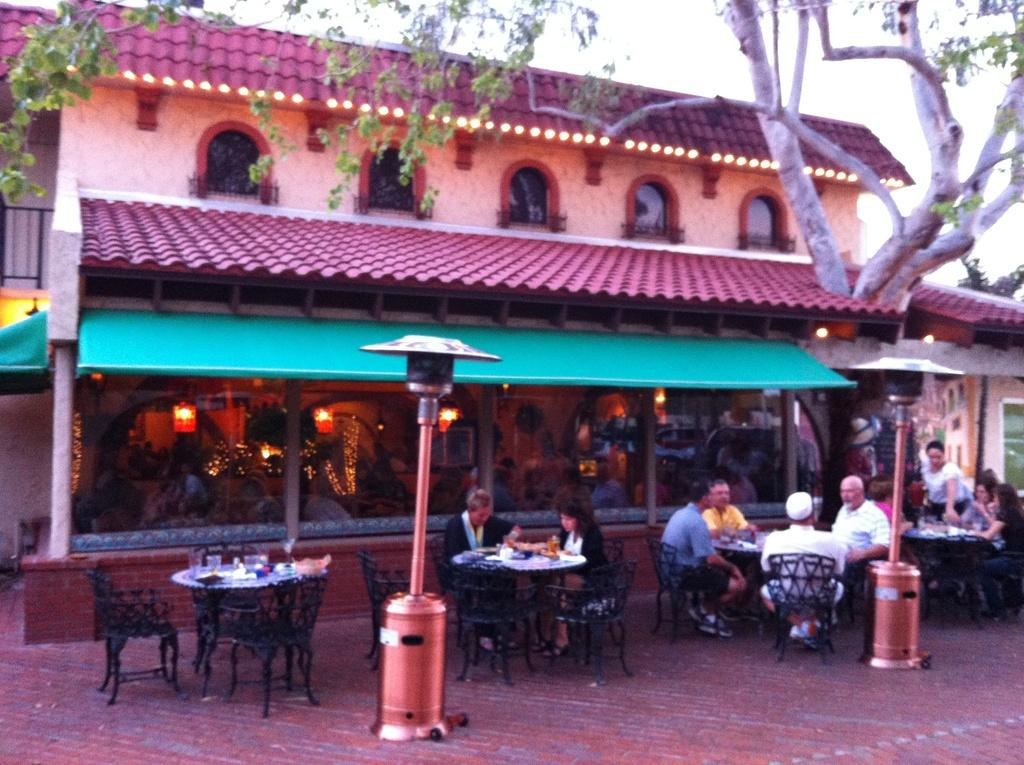How many people are in the image? There is a group of people in the image, but the exact number is not specified. What are the people doing in the image? The people are sitting on chairs in the image. What is the background of the image? The people are in front of a building, and there is a tree in the image as well. What can be seen above the people and the building? The sky is visible in the image. Reasoning: Let' Let's think step by step in order to produce the conversation. We start by acknowledging the presence of a group of people in the image. Then, we describe their actions, which are sitting on chairs. Next, we mention the background, which includes a building and a tree. Finally, we note the presence of the sky in the image. We avoid asking questions that cannot be answered definitively with the given facts and ensure that the language is simple and clear. Absurd Question/Answer: What type of apple is being used for the game of volleyball in the image? There is no apple or game of volleyball present in the image. 